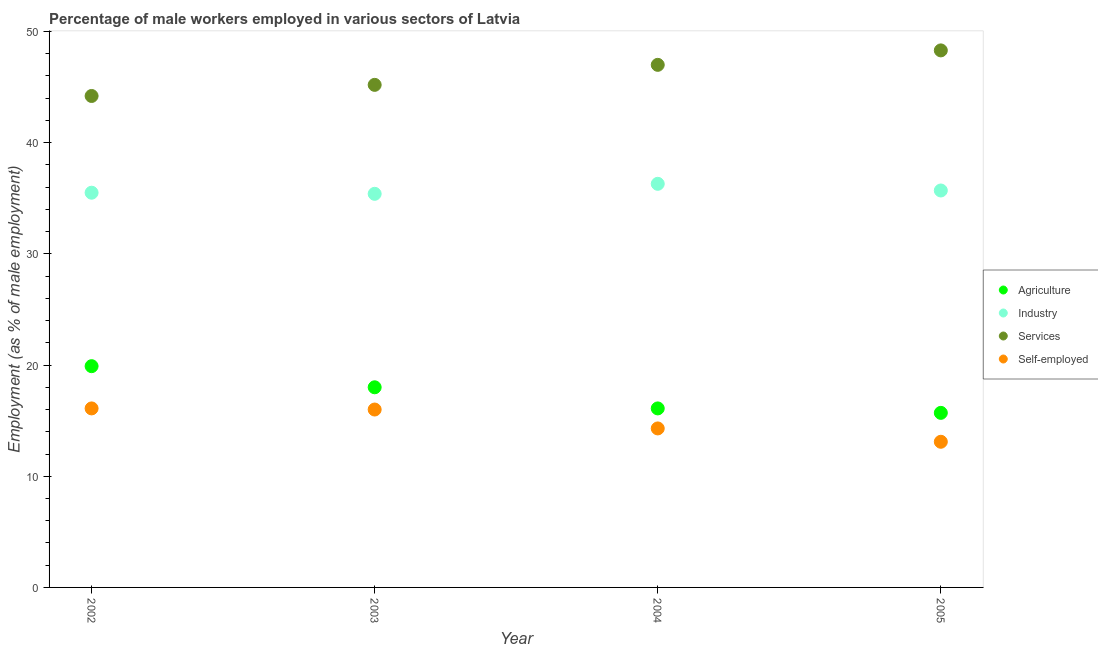What is the percentage of male workers in services in 2003?
Offer a very short reply. 45.2. Across all years, what is the maximum percentage of male workers in agriculture?
Your response must be concise. 19.9. Across all years, what is the minimum percentage of male workers in industry?
Provide a succinct answer. 35.4. What is the total percentage of male workers in services in the graph?
Give a very brief answer. 184.7. What is the difference between the percentage of male workers in industry in 2004 and that in 2005?
Offer a terse response. 0.6. What is the difference between the percentage of self employed male workers in 2004 and the percentage of male workers in agriculture in 2005?
Ensure brevity in your answer.  -1.4. What is the average percentage of self employed male workers per year?
Provide a short and direct response. 14.88. In the year 2005, what is the difference between the percentage of male workers in services and percentage of male workers in industry?
Your answer should be compact. 12.6. What is the ratio of the percentage of male workers in industry in 2002 to that in 2004?
Provide a succinct answer. 0.98. Is the percentage of male workers in industry in 2003 less than that in 2005?
Provide a succinct answer. Yes. Is the difference between the percentage of self employed male workers in 2002 and 2005 greater than the difference between the percentage of male workers in industry in 2002 and 2005?
Give a very brief answer. Yes. What is the difference between the highest and the second highest percentage of self employed male workers?
Keep it short and to the point. 0.1. What is the difference between the highest and the lowest percentage of self employed male workers?
Provide a succinct answer. 3. In how many years, is the percentage of male workers in services greater than the average percentage of male workers in services taken over all years?
Ensure brevity in your answer.  2. Is it the case that in every year, the sum of the percentage of male workers in services and percentage of male workers in industry is greater than the sum of percentage of self employed male workers and percentage of male workers in agriculture?
Provide a succinct answer. Yes. Is it the case that in every year, the sum of the percentage of male workers in agriculture and percentage of male workers in industry is greater than the percentage of male workers in services?
Your answer should be compact. Yes. Does the percentage of male workers in agriculture monotonically increase over the years?
Give a very brief answer. No. Is the percentage of male workers in agriculture strictly greater than the percentage of self employed male workers over the years?
Offer a very short reply. Yes. How many dotlines are there?
Provide a succinct answer. 4. How many years are there in the graph?
Offer a very short reply. 4. Are the values on the major ticks of Y-axis written in scientific E-notation?
Your response must be concise. No. Does the graph contain grids?
Offer a terse response. No. Where does the legend appear in the graph?
Offer a very short reply. Center right. What is the title of the graph?
Provide a short and direct response. Percentage of male workers employed in various sectors of Latvia. Does "UNDP" appear as one of the legend labels in the graph?
Your response must be concise. No. What is the label or title of the X-axis?
Your answer should be compact. Year. What is the label or title of the Y-axis?
Your answer should be very brief. Employment (as % of male employment). What is the Employment (as % of male employment) in Agriculture in 2002?
Provide a short and direct response. 19.9. What is the Employment (as % of male employment) of Industry in 2002?
Your answer should be compact. 35.5. What is the Employment (as % of male employment) of Services in 2002?
Provide a succinct answer. 44.2. What is the Employment (as % of male employment) of Self-employed in 2002?
Provide a succinct answer. 16.1. What is the Employment (as % of male employment) of Agriculture in 2003?
Ensure brevity in your answer.  18. What is the Employment (as % of male employment) in Industry in 2003?
Keep it short and to the point. 35.4. What is the Employment (as % of male employment) in Services in 2003?
Provide a succinct answer. 45.2. What is the Employment (as % of male employment) in Self-employed in 2003?
Your answer should be compact. 16. What is the Employment (as % of male employment) in Agriculture in 2004?
Offer a very short reply. 16.1. What is the Employment (as % of male employment) in Industry in 2004?
Offer a very short reply. 36.3. What is the Employment (as % of male employment) of Services in 2004?
Offer a terse response. 47. What is the Employment (as % of male employment) in Self-employed in 2004?
Ensure brevity in your answer.  14.3. What is the Employment (as % of male employment) of Agriculture in 2005?
Provide a short and direct response. 15.7. What is the Employment (as % of male employment) in Industry in 2005?
Provide a short and direct response. 35.7. What is the Employment (as % of male employment) of Services in 2005?
Keep it short and to the point. 48.3. What is the Employment (as % of male employment) of Self-employed in 2005?
Offer a very short reply. 13.1. Across all years, what is the maximum Employment (as % of male employment) in Agriculture?
Provide a short and direct response. 19.9. Across all years, what is the maximum Employment (as % of male employment) in Industry?
Offer a very short reply. 36.3. Across all years, what is the maximum Employment (as % of male employment) in Services?
Offer a very short reply. 48.3. Across all years, what is the maximum Employment (as % of male employment) of Self-employed?
Provide a succinct answer. 16.1. Across all years, what is the minimum Employment (as % of male employment) in Agriculture?
Your response must be concise. 15.7. Across all years, what is the minimum Employment (as % of male employment) of Industry?
Ensure brevity in your answer.  35.4. Across all years, what is the minimum Employment (as % of male employment) of Services?
Make the answer very short. 44.2. Across all years, what is the minimum Employment (as % of male employment) in Self-employed?
Keep it short and to the point. 13.1. What is the total Employment (as % of male employment) of Agriculture in the graph?
Your response must be concise. 69.7. What is the total Employment (as % of male employment) in Industry in the graph?
Your answer should be very brief. 142.9. What is the total Employment (as % of male employment) of Services in the graph?
Your answer should be compact. 184.7. What is the total Employment (as % of male employment) of Self-employed in the graph?
Keep it short and to the point. 59.5. What is the difference between the Employment (as % of male employment) in Agriculture in 2002 and that in 2003?
Keep it short and to the point. 1.9. What is the difference between the Employment (as % of male employment) in Industry in 2002 and that in 2003?
Provide a short and direct response. 0.1. What is the difference between the Employment (as % of male employment) in Industry in 2002 and that in 2004?
Offer a terse response. -0.8. What is the difference between the Employment (as % of male employment) of Agriculture in 2002 and that in 2005?
Offer a very short reply. 4.2. What is the difference between the Employment (as % of male employment) in Services in 2002 and that in 2005?
Your response must be concise. -4.1. What is the difference between the Employment (as % of male employment) of Agriculture in 2003 and that in 2004?
Your response must be concise. 1.9. What is the difference between the Employment (as % of male employment) in Industry in 2003 and that in 2004?
Provide a succinct answer. -0.9. What is the difference between the Employment (as % of male employment) of Agriculture in 2003 and that in 2005?
Offer a very short reply. 2.3. What is the difference between the Employment (as % of male employment) of Industry in 2003 and that in 2005?
Your response must be concise. -0.3. What is the difference between the Employment (as % of male employment) in Services in 2003 and that in 2005?
Offer a terse response. -3.1. What is the difference between the Employment (as % of male employment) of Industry in 2004 and that in 2005?
Keep it short and to the point. 0.6. What is the difference between the Employment (as % of male employment) in Agriculture in 2002 and the Employment (as % of male employment) in Industry in 2003?
Make the answer very short. -15.5. What is the difference between the Employment (as % of male employment) of Agriculture in 2002 and the Employment (as % of male employment) of Services in 2003?
Make the answer very short. -25.3. What is the difference between the Employment (as % of male employment) of Agriculture in 2002 and the Employment (as % of male employment) of Self-employed in 2003?
Offer a terse response. 3.9. What is the difference between the Employment (as % of male employment) in Services in 2002 and the Employment (as % of male employment) in Self-employed in 2003?
Make the answer very short. 28.2. What is the difference between the Employment (as % of male employment) in Agriculture in 2002 and the Employment (as % of male employment) in Industry in 2004?
Offer a terse response. -16.4. What is the difference between the Employment (as % of male employment) of Agriculture in 2002 and the Employment (as % of male employment) of Services in 2004?
Make the answer very short. -27.1. What is the difference between the Employment (as % of male employment) in Industry in 2002 and the Employment (as % of male employment) in Services in 2004?
Keep it short and to the point. -11.5. What is the difference between the Employment (as % of male employment) in Industry in 2002 and the Employment (as % of male employment) in Self-employed in 2004?
Keep it short and to the point. 21.2. What is the difference between the Employment (as % of male employment) of Services in 2002 and the Employment (as % of male employment) of Self-employed in 2004?
Your answer should be very brief. 29.9. What is the difference between the Employment (as % of male employment) in Agriculture in 2002 and the Employment (as % of male employment) in Industry in 2005?
Provide a succinct answer. -15.8. What is the difference between the Employment (as % of male employment) in Agriculture in 2002 and the Employment (as % of male employment) in Services in 2005?
Ensure brevity in your answer.  -28.4. What is the difference between the Employment (as % of male employment) of Industry in 2002 and the Employment (as % of male employment) of Services in 2005?
Offer a very short reply. -12.8. What is the difference between the Employment (as % of male employment) in Industry in 2002 and the Employment (as % of male employment) in Self-employed in 2005?
Your response must be concise. 22.4. What is the difference between the Employment (as % of male employment) of Services in 2002 and the Employment (as % of male employment) of Self-employed in 2005?
Make the answer very short. 31.1. What is the difference between the Employment (as % of male employment) of Agriculture in 2003 and the Employment (as % of male employment) of Industry in 2004?
Provide a short and direct response. -18.3. What is the difference between the Employment (as % of male employment) of Agriculture in 2003 and the Employment (as % of male employment) of Self-employed in 2004?
Keep it short and to the point. 3.7. What is the difference between the Employment (as % of male employment) in Industry in 2003 and the Employment (as % of male employment) in Services in 2004?
Make the answer very short. -11.6. What is the difference between the Employment (as % of male employment) of Industry in 2003 and the Employment (as % of male employment) of Self-employed in 2004?
Provide a succinct answer. 21.1. What is the difference between the Employment (as % of male employment) in Services in 2003 and the Employment (as % of male employment) in Self-employed in 2004?
Your response must be concise. 30.9. What is the difference between the Employment (as % of male employment) of Agriculture in 2003 and the Employment (as % of male employment) of Industry in 2005?
Your answer should be very brief. -17.7. What is the difference between the Employment (as % of male employment) in Agriculture in 2003 and the Employment (as % of male employment) in Services in 2005?
Your answer should be compact. -30.3. What is the difference between the Employment (as % of male employment) of Agriculture in 2003 and the Employment (as % of male employment) of Self-employed in 2005?
Give a very brief answer. 4.9. What is the difference between the Employment (as % of male employment) in Industry in 2003 and the Employment (as % of male employment) in Self-employed in 2005?
Provide a short and direct response. 22.3. What is the difference between the Employment (as % of male employment) in Services in 2003 and the Employment (as % of male employment) in Self-employed in 2005?
Offer a very short reply. 32.1. What is the difference between the Employment (as % of male employment) in Agriculture in 2004 and the Employment (as % of male employment) in Industry in 2005?
Provide a short and direct response. -19.6. What is the difference between the Employment (as % of male employment) of Agriculture in 2004 and the Employment (as % of male employment) of Services in 2005?
Make the answer very short. -32.2. What is the difference between the Employment (as % of male employment) in Agriculture in 2004 and the Employment (as % of male employment) in Self-employed in 2005?
Make the answer very short. 3. What is the difference between the Employment (as % of male employment) of Industry in 2004 and the Employment (as % of male employment) of Self-employed in 2005?
Offer a very short reply. 23.2. What is the difference between the Employment (as % of male employment) of Services in 2004 and the Employment (as % of male employment) of Self-employed in 2005?
Keep it short and to the point. 33.9. What is the average Employment (as % of male employment) of Agriculture per year?
Provide a succinct answer. 17.43. What is the average Employment (as % of male employment) of Industry per year?
Provide a succinct answer. 35.73. What is the average Employment (as % of male employment) in Services per year?
Your answer should be very brief. 46.17. What is the average Employment (as % of male employment) in Self-employed per year?
Give a very brief answer. 14.88. In the year 2002, what is the difference between the Employment (as % of male employment) in Agriculture and Employment (as % of male employment) in Industry?
Offer a very short reply. -15.6. In the year 2002, what is the difference between the Employment (as % of male employment) in Agriculture and Employment (as % of male employment) in Services?
Offer a very short reply. -24.3. In the year 2002, what is the difference between the Employment (as % of male employment) of Industry and Employment (as % of male employment) of Services?
Keep it short and to the point. -8.7. In the year 2002, what is the difference between the Employment (as % of male employment) in Services and Employment (as % of male employment) in Self-employed?
Keep it short and to the point. 28.1. In the year 2003, what is the difference between the Employment (as % of male employment) of Agriculture and Employment (as % of male employment) of Industry?
Provide a short and direct response. -17.4. In the year 2003, what is the difference between the Employment (as % of male employment) of Agriculture and Employment (as % of male employment) of Services?
Give a very brief answer. -27.2. In the year 2003, what is the difference between the Employment (as % of male employment) of Services and Employment (as % of male employment) of Self-employed?
Provide a short and direct response. 29.2. In the year 2004, what is the difference between the Employment (as % of male employment) in Agriculture and Employment (as % of male employment) in Industry?
Offer a very short reply. -20.2. In the year 2004, what is the difference between the Employment (as % of male employment) of Agriculture and Employment (as % of male employment) of Services?
Offer a terse response. -30.9. In the year 2004, what is the difference between the Employment (as % of male employment) in Agriculture and Employment (as % of male employment) in Self-employed?
Your answer should be very brief. 1.8. In the year 2004, what is the difference between the Employment (as % of male employment) of Industry and Employment (as % of male employment) of Services?
Offer a terse response. -10.7. In the year 2004, what is the difference between the Employment (as % of male employment) in Industry and Employment (as % of male employment) in Self-employed?
Your answer should be compact. 22. In the year 2004, what is the difference between the Employment (as % of male employment) of Services and Employment (as % of male employment) of Self-employed?
Give a very brief answer. 32.7. In the year 2005, what is the difference between the Employment (as % of male employment) of Agriculture and Employment (as % of male employment) of Services?
Offer a terse response. -32.6. In the year 2005, what is the difference between the Employment (as % of male employment) in Industry and Employment (as % of male employment) in Self-employed?
Provide a succinct answer. 22.6. In the year 2005, what is the difference between the Employment (as % of male employment) in Services and Employment (as % of male employment) in Self-employed?
Provide a succinct answer. 35.2. What is the ratio of the Employment (as % of male employment) of Agriculture in 2002 to that in 2003?
Give a very brief answer. 1.11. What is the ratio of the Employment (as % of male employment) in Services in 2002 to that in 2003?
Your response must be concise. 0.98. What is the ratio of the Employment (as % of male employment) of Agriculture in 2002 to that in 2004?
Your response must be concise. 1.24. What is the ratio of the Employment (as % of male employment) of Services in 2002 to that in 2004?
Your answer should be very brief. 0.94. What is the ratio of the Employment (as % of male employment) of Self-employed in 2002 to that in 2004?
Give a very brief answer. 1.13. What is the ratio of the Employment (as % of male employment) in Agriculture in 2002 to that in 2005?
Provide a succinct answer. 1.27. What is the ratio of the Employment (as % of male employment) in Services in 2002 to that in 2005?
Make the answer very short. 0.92. What is the ratio of the Employment (as % of male employment) of Self-employed in 2002 to that in 2005?
Keep it short and to the point. 1.23. What is the ratio of the Employment (as % of male employment) of Agriculture in 2003 to that in 2004?
Give a very brief answer. 1.12. What is the ratio of the Employment (as % of male employment) in Industry in 2003 to that in 2004?
Provide a succinct answer. 0.98. What is the ratio of the Employment (as % of male employment) in Services in 2003 to that in 2004?
Offer a very short reply. 0.96. What is the ratio of the Employment (as % of male employment) of Self-employed in 2003 to that in 2004?
Offer a terse response. 1.12. What is the ratio of the Employment (as % of male employment) of Agriculture in 2003 to that in 2005?
Keep it short and to the point. 1.15. What is the ratio of the Employment (as % of male employment) of Services in 2003 to that in 2005?
Keep it short and to the point. 0.94. What is the ratio of the Employment (as % of male employment) in Self-employed in 2003 to that in 2005?
Provide a succinct answer. 1.22. What is the ratio of the Employment (as % of male employment) of Agriculture in 2004 to that in 2005?
Your response must be concise. 1.03. What is the ratio of the Employment (as % of male employment) of Industry in 2004 to that in 2005?
Give a very brief answer. 1.02. What is the ratio of the Employment (as % of male employment) of Services in 2004 to that in 2005?
Make the answer very short. 0.97. What is the ratio of the Employment (as % of male employment) of Self-employed in 2004 to that in 2005?
Ensure brevity in your answer.  1.09. What is the difference between the highest and the second highest Employment (as % of male employment) of Agriculture?
Keep it short and to the point. 1.9. What is the difference between the highest and the second highest Employment (as % of male employment) of Industry?
Keep it short and to the point. 0.6. What is the difference between the highest and the second highest Employment (as % of male employment) in Services?
Your answer should be very brief. 1.3. What is the difference between the highest and the lowest Employment (as % of male employment) in Agriculture?
Provide a succinct answer. 4.2. What is the difference between the highest and the lowest Employment (as % of male employment) in Services?
Make the answer very short. 4.1. What is the difference between the highest and the lowest Employment (as % of male employment) of Self-employed?
Ensure brevity in your answer.  3. 